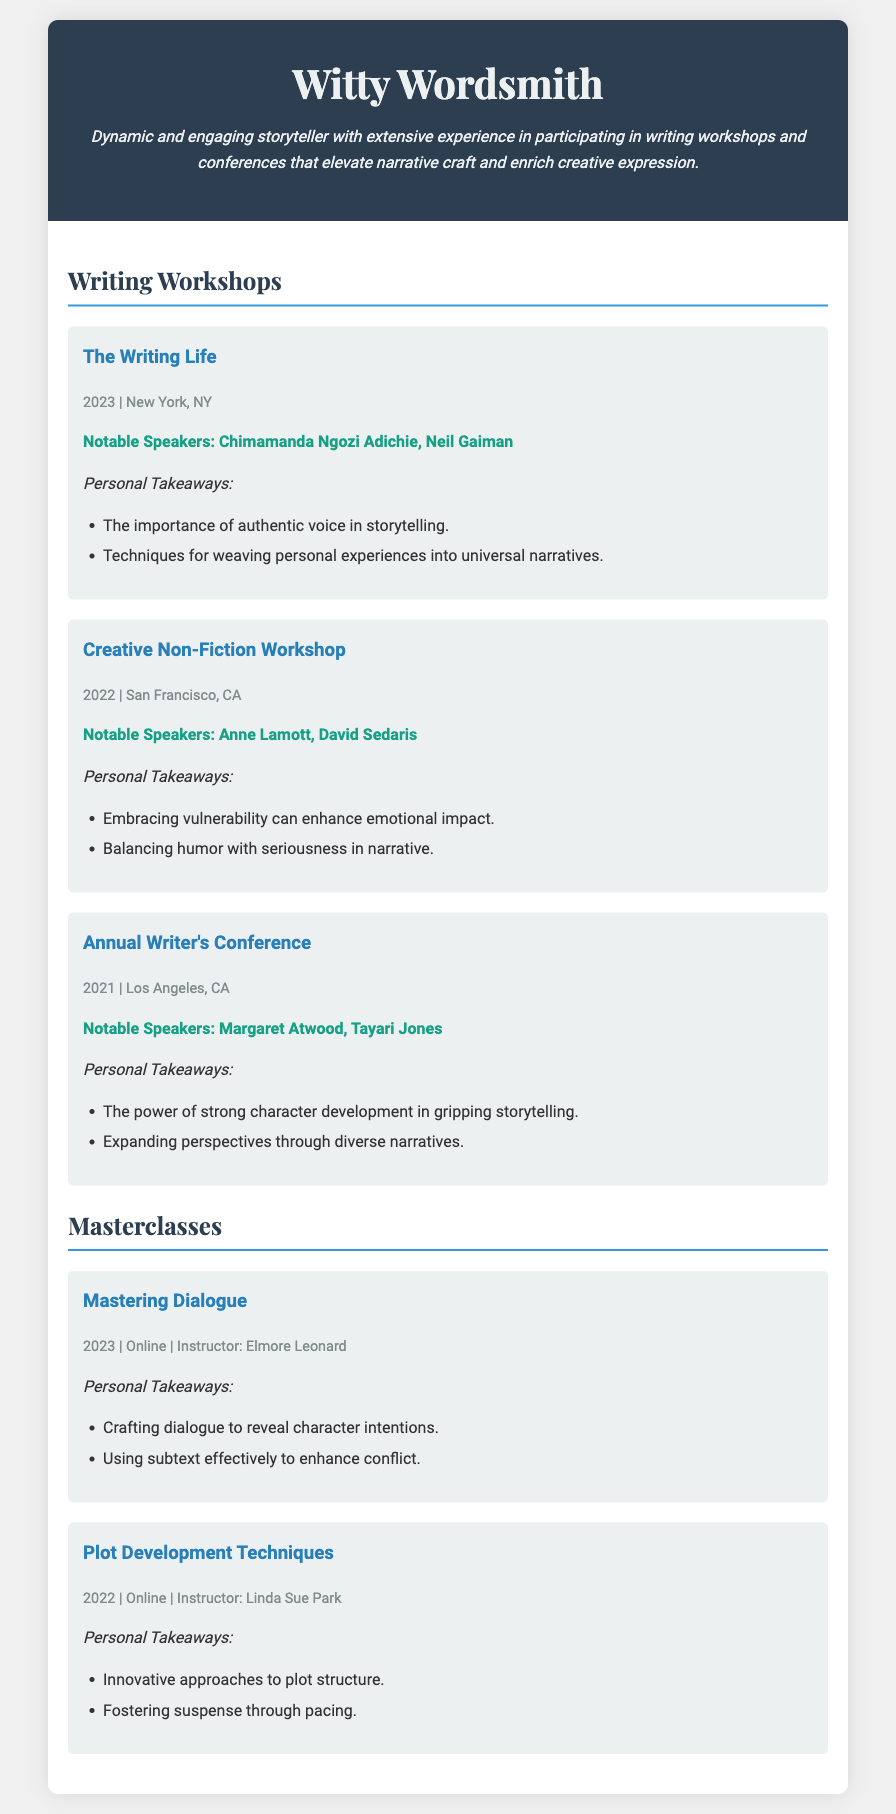What is the title of the resume? The title of the resume is presented prominently at the top of the document.
Answer: Witty Wordsmith In which city was "The Writing Life" workshop held? The workshop location is noted next to the title of the workshop in the document.
Answer: New York, NY Who were two notable speakers at the "Creative Non-Fiction Workshop"? The document lists the notable speakers for each workshop clearly.
Answer: Anne Lamott, David Sedaris What year did the "Mastering Dialogue" masterclass take place? The year is mentioned next to the title and location details of the masterclass.
Answer: 2023 What is a personal takeaway from the "Annual Writer's Conference"? The takeaways are listed beneath each workshop title.
Answer: The power of strong character development in gripping storytelling Name one technique learned from the "Mastering Dialogue" masterclass. The techniques are specifically mentioned in the takeaways section for each masterclass.
Answer: Crafting dialogue to reveal character intentions Which notable speaker is associated with the "Plot Development Techniques" masterclass? The instructor's name is mentioned as part of the masterclass details.
Answer: Linda Sue Park What is the format of the "Mastering Dialogue" masterclass? This refers to how the masterclass was delivered, indicated in the document.
Answer: Online 